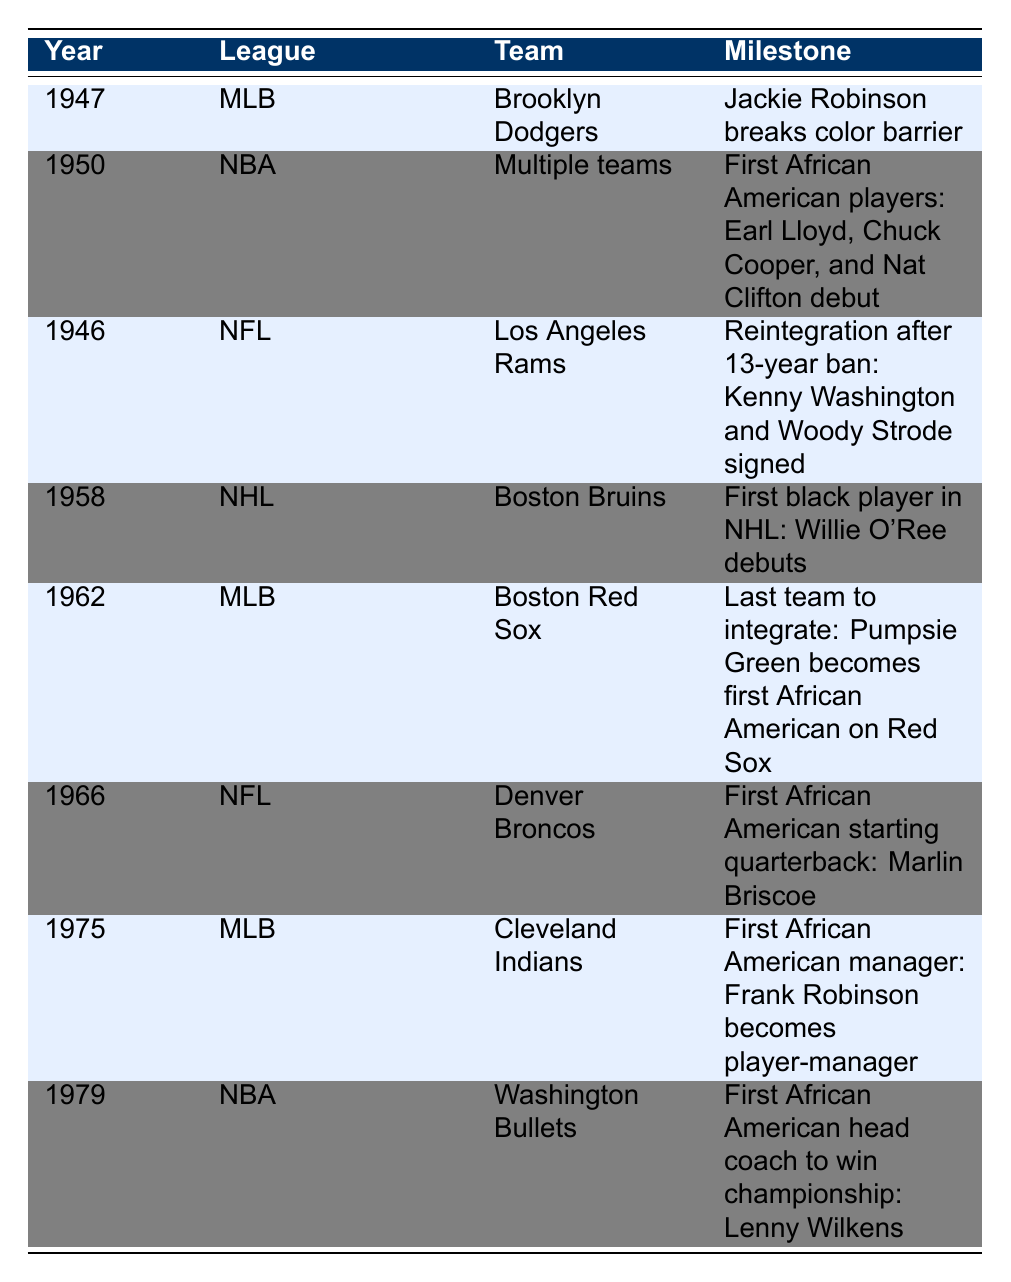What year did Jackie Robinson break the color barrier in Major League Baseball? The table shows that Jackie Robinson broke the color barrier in MLB in 1947.
Answer: 1947 Which league first integrated by allowing African American players in 1950? The table indicates that the NBA allowed its first African American players in 1950.
Answer: NBA Who was the first African American player in the NHL? The table states that Willie O'Ree was the first African American player in the NHL, debuting with the Boston Bruins in 1958.
Answer: Willie O'Ree Which team was the last in Major League Baseball to integrate? The last team in MLB to integrate was the Boston Red Sox, according to the table, which occurred in 1962.
Answer: Boston Red Sox How many leagues had milestones related to racial integration listed in the table? There are four leagues listed in the table: MLB, NBA, NFL, and NHL, each with at least one milestone related to racial integration.
Answer: 4 What event took place in the NFL in 1966? The table notes that in 1966, Marlin Briscoe became the first African American starting quarterback in the NFL.
Answer: Marlin Briscoe becoming the first African American starting quarterback Was the first African American manager in Major League Baseball in the 1970s? Yes, the table indicates that Frank Robinson became the first African American manager in MLB in 1975, which falls within the 1970s.
Answer: Yes In which year and league did the first African American head coach win a championship? The table shows that Lenny Wilkens, an African American head coach, won a championship with the Washington Bullets in 1979, in the NBA.
Answer: 1979, NBA How many years were there between Jackie Robinson breaking the color barrier and the first African American player debuting in the NBA? Jackie Robinson broke the color barrier in MLB in 1947, and the first African American players debuted in the NBA in 1950. The difference is 1950 - 1947 = 3 years.
Answer: 3 years What significant integration milestone happened in the NFL after a 13-year ban, and when did it occur? The table highlights that in 1946, the NFL reintegrated after a 13-year ban, with Kenny Washington and Woody Strode being signed by the Los Angeles Rams.
Answer: NFL reintegration in 1946 How many years passed from the first African American players in the NBA to the first African American manager in MLB? The first African American players in the NBA debuted in 1950 and the first African American manager in MLB was in 1975. Therefore, the difference is 1975 - 1950 = 25 years.
Answer: 25 years 